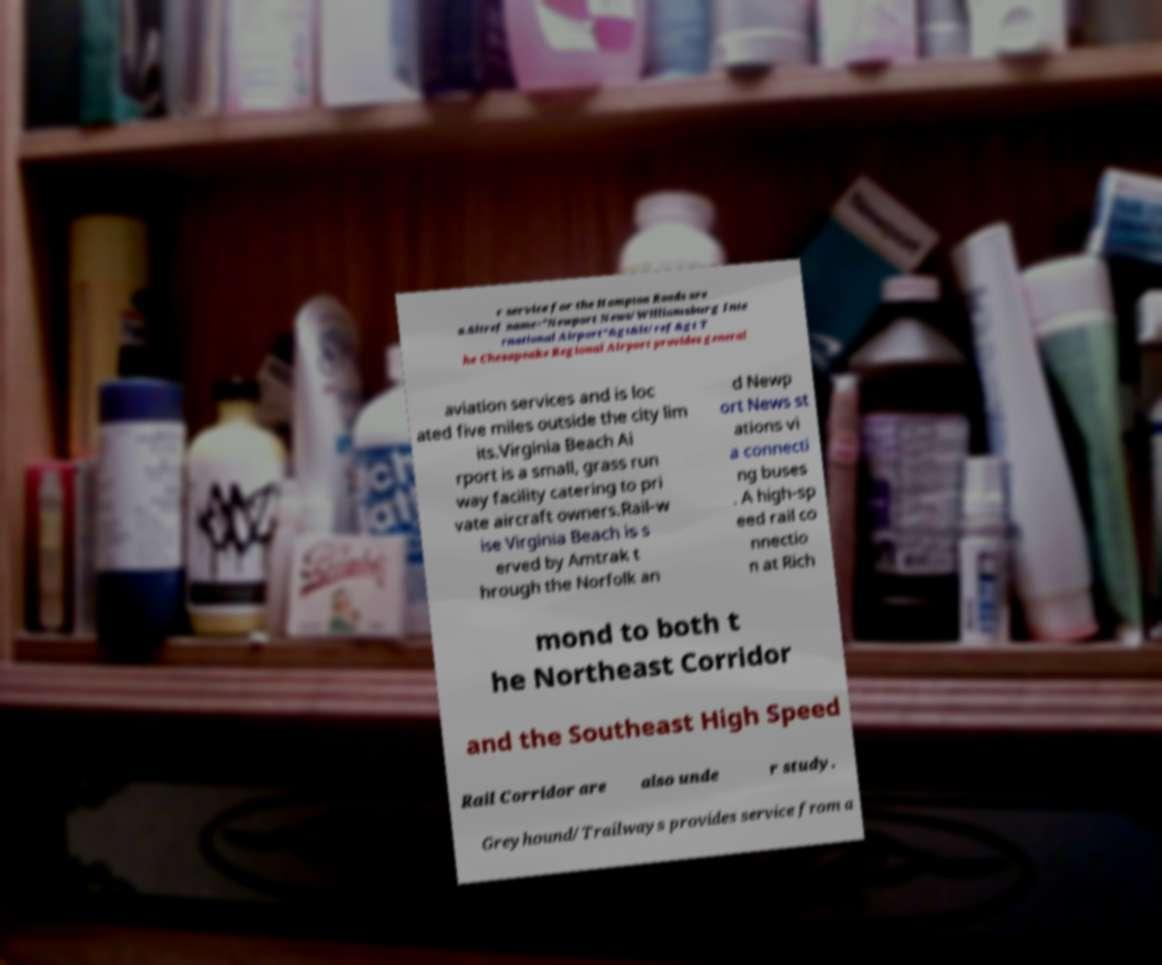Can you read and provide the text displayed in the image?This photo seems to have some interesting text. Can you extract and type it out for me? r service for the Hampton Roads are a.&ltref name="Newport News/Williamsburg Inte rnational Airport"&gt&lt/ref&gt T he Chesapeake Regional Airport provides general aviation services and is loc ated five miles outside the city lim its.Virginia Beach Ai rport is a small, grass run way facility catering to pri vate aircraft owners.Rail-w ise Virginia Beach is s erved by Amtrak t hrough the Norfolk an d Newp ort News st ations vi a connecti ng buses . A high-sp eed rail co nnectio n at Rich mond to both t he Northeast Corridor and the Southeast High Speed Rail Corridor are also unde r study. Greyhound/Trailways provides service from a 